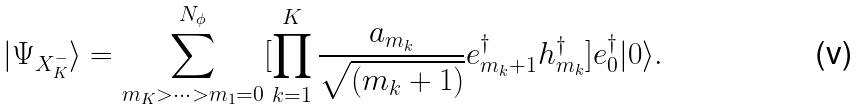<formula> <loc_0><loc_0><loc_500><loc_500>| \Psi _ { X ^ { - } _ { K } } \rangle = \sum ^ { N _ { \phi } } _ { m _ { K } > \cdots > m _ { 1 } = 0 } [ \prod _ { k = 1 } ^ { K } \frac { a _ { m _ { k } } } { \sqrt { ( m _ { k } + 1 ) } } e ^ { \dagger } _ { m _ { k } + 1 } h ^ { \dagger } _ { m _ { k } } ] e ^ { \dagger } _ { 0 } | 0 \rangle .</formula> 